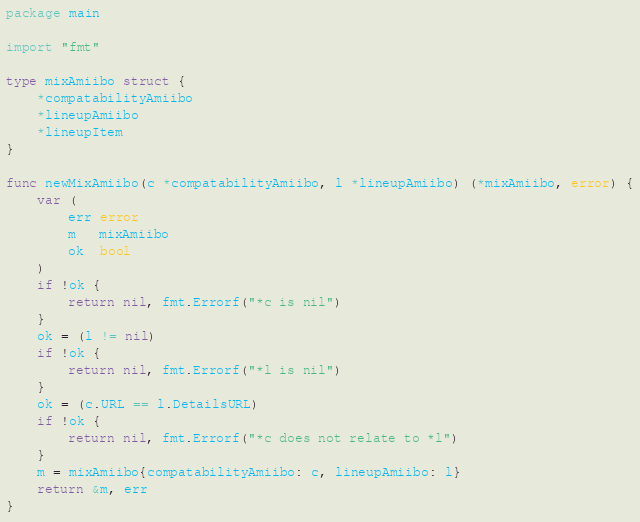Convert code to text. <code><loc_0><loc_0><loc_500><loc_500><_Go_>package main

import "fmt"

type mixAmiibo struct {
	*compatabilityAmiibo
	*lineupAmiibo
	*lineupItem
}

func newMixAmiibo(c *compatabilityAmiibo, l *lineupAmiibo) (*mixAmiibo, error) {
	var (
		err error
		m   mixAmiibo
		ok  bool
	)
	if !ok {
		return nil, fmt.Errorf("*c is nil")
	}
	ok = (l != nil)
	if !ok {
		return nil, fmt.Errorf("*l is nil")
	}
	ok = (c.URL == l.DetailsURL)
	if !ok {
		return nil, fmt.Errorf("*c does not relate to *l")
	}
	m = mixAmiibo{compatabilityAmiibo: c, lineupAmiibo: l}
	return &m, err
}
</code> 